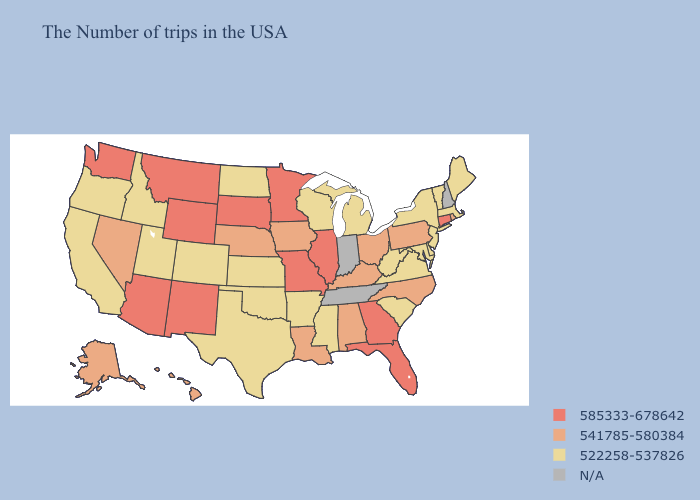Among the states that border New Mexico , does Arizona have the lowest value?
Keep it brief. No. Name the states that have a value in the range 585333-678642?
Concise answer only. Connecticut, Florida, Georgia, Illinois, Missouri, Minnesota, South Dakota, Wyoming, New Mexico, Montana, Arizona, Washington. What is the highest value in the USA?
Short answer required. 585333-678642. What is the lowest value in the USA?
Short answer required. 522258-537826. Is the legend a continuous bar?
Write a very short answer. No. How many symbols are there in the legend?
Keep it brief. 4. What is the lowest value in the MidWest?
Concise answer only. 522258-537826. What is the value of Texas?
Give a very brief answer. 522258-537826. What is the value of Nebraska?
Write a very short answer. 541785-580384. 